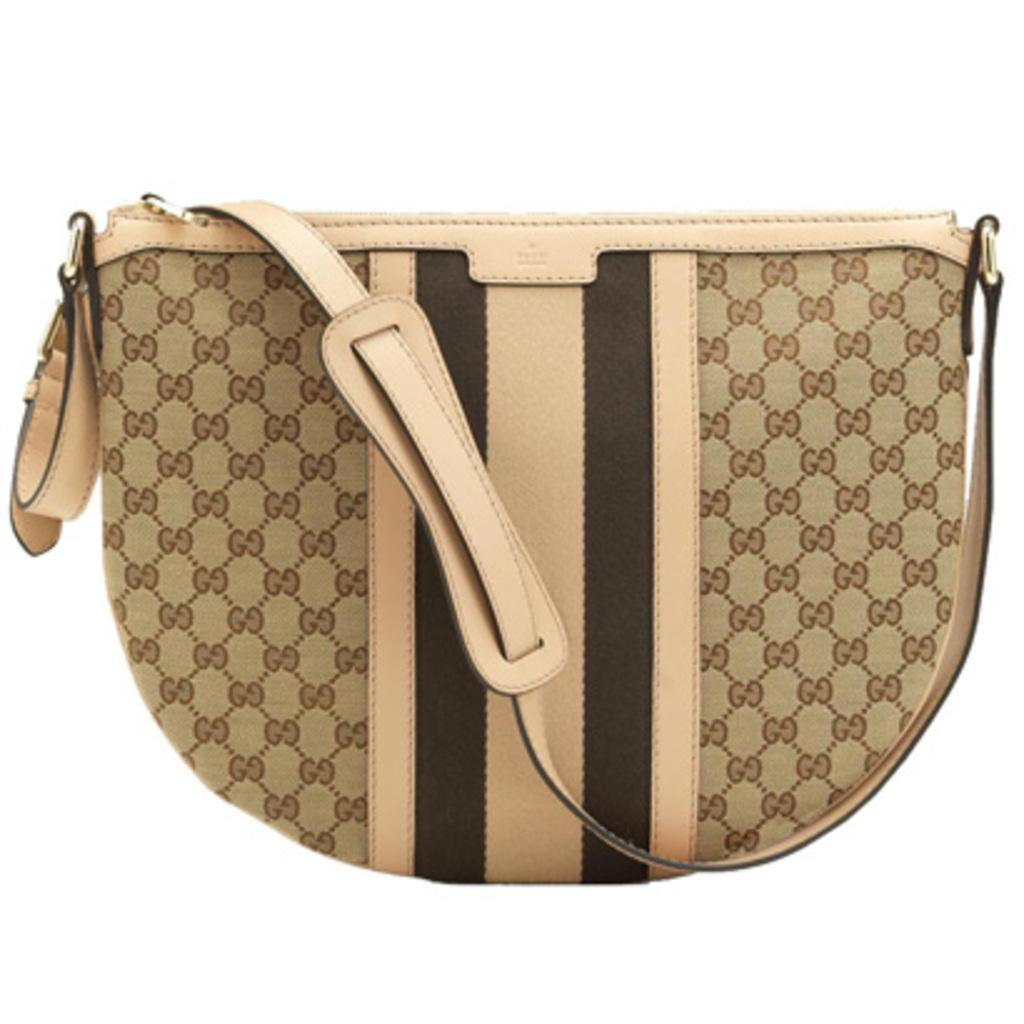What type of accessory is featured in the image? There is a women's handbag in the image. What material is the handbag made of? The handbag is made of leather. Are there any additional features hanging from the handbag? Yes, there is a zip and a ring hanging from the handbag. What type of whip is hanging from the handbag in the image? There is no whip present in the image; it features a zip and a ring hanging from the handbag. How does the handbag contribute to the overall system in the image? The image does not depict a system, and the handbag is not shown to be part of any system. 